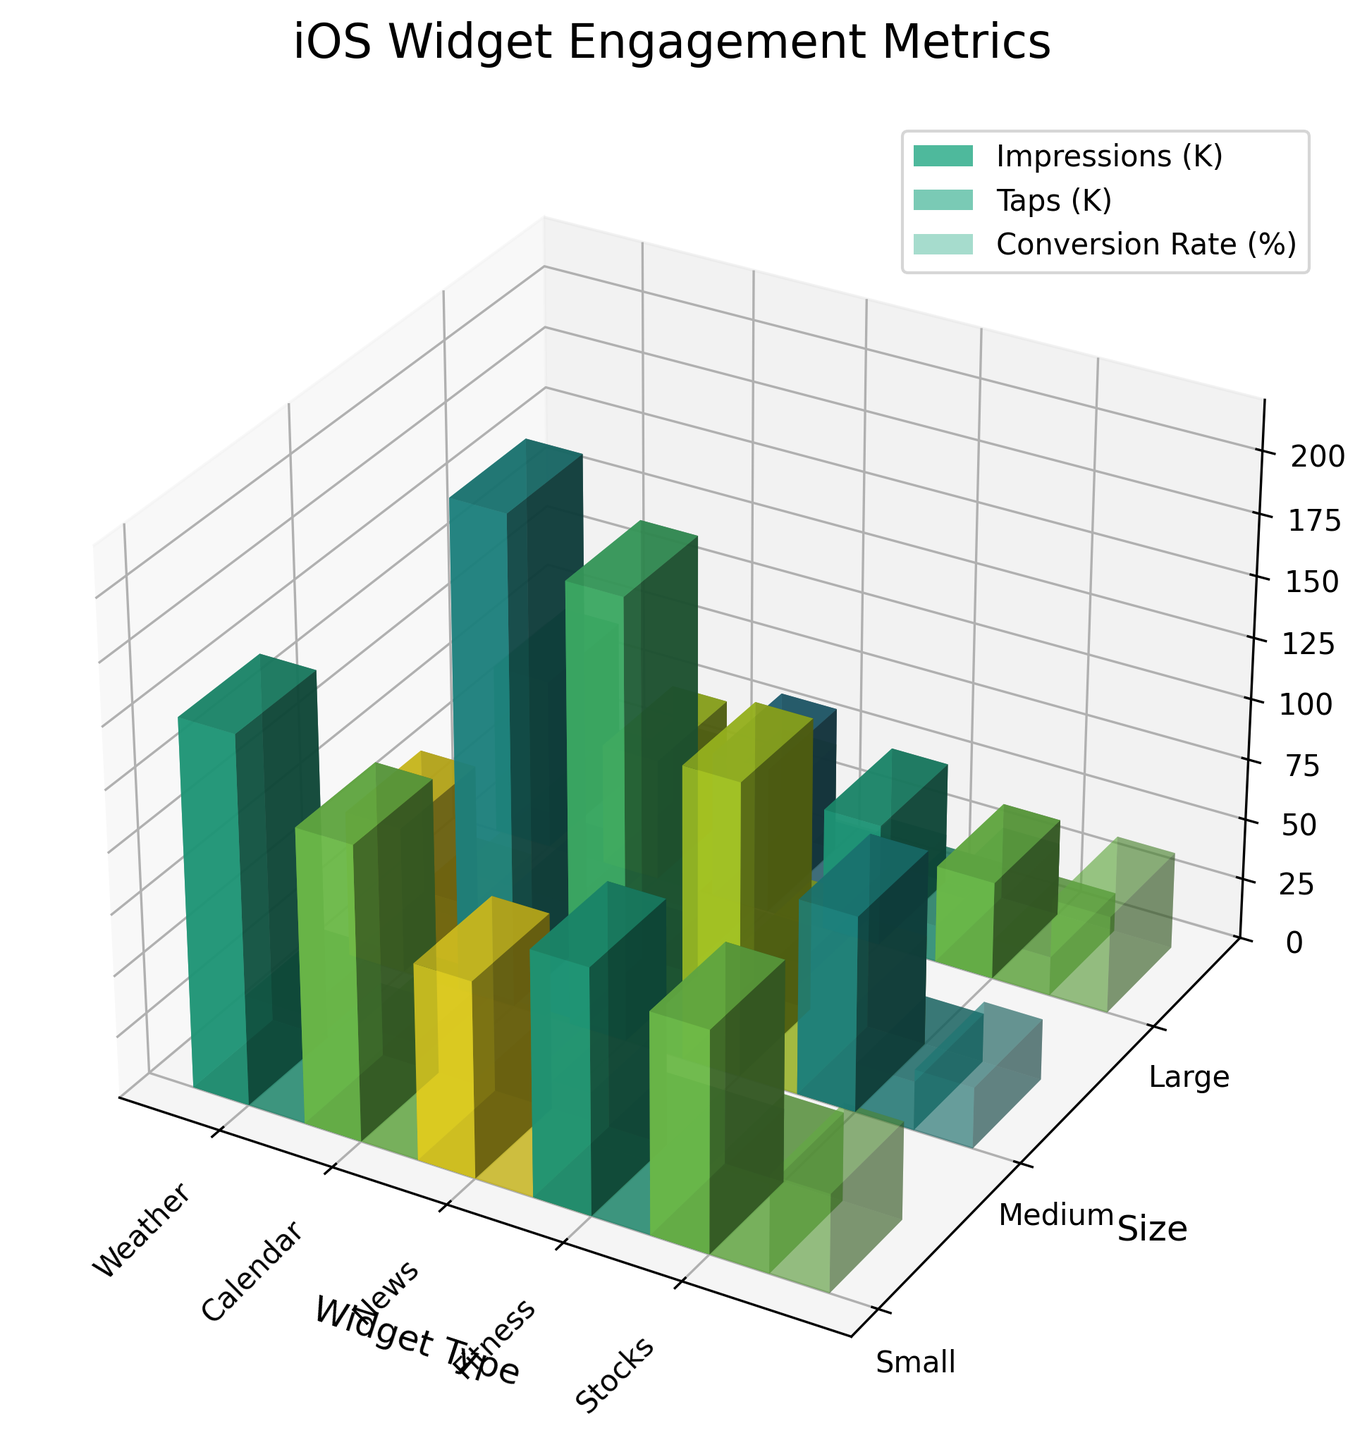What's the title of the plot? The title is usually placed at the top of the plot and reflects the overall content or data being visualized. Here, the title appears as "iOS Widget Engagement Metrics."
Answer: iOS Widget Engagement Metrics What are the axes labels in the 3D bar plot? Axes labels are typically placed alongside the axes to describe what data they represent. In this plot, the x-axis is labeled "Widget Type," the y-axis is "Size," and the z-axis is "Metrics."
Answer: Widget Type, Size, Metrics What are the categories represented on the x-axis? The x-axis shows different widget types, which are available as textual tick marks. In this plot, the x-axis categories are "Weather," "Calendar," "News," "Fitness," and "Stocks."
Answer: Weather, Calendar, News, Fitness, Stocks Which widget type and size combination has the highest impressions? Identify the tallest bar in the impressions section (right-most part), which corresponds to both the widget type (x-axis tick) and size (y-axis tick). The "News, Small" combination has the highest impressions.
Answer: News, Small On average, which widget type has the highest conversion rate? To find the average, add up the conversion rates for all sizes within each widget type and divide by the number of sizes. For "Weather," the average is (30 + 40 + 50) / 3 = 40. Repeating this calculation for all widget types, "Weather" consistently shows the highest average conversion rate of 40%.
Answer: Weather For the "Fitness" widget, how many more taps does the Medium size get compared to the Large size? Look at the "Fitness" category, and then compare the heights of the Medium and Large bars for taps; Medium has 24.5K taps, and Large has 22.5K taps. The difference is 24.5K - 22.5K = 2K taps.
Answer: 2K taps Which size generally shows the highest conversion rate across all widget types? Compare the conversion rate bars (right-most bars in each group) for different sizes (Small, Medium, Large). The Large size consistently shows the highest conversion rates for all widget types.
Answer: Large 